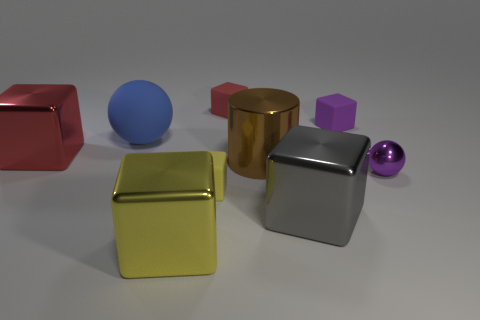Subtract 1 cubes. How many cubes are left? 5 Subtract all purple cubes. How many cubes are left? 5 Subtract all yellow metal blocks. How many blocks are left? 5 Subtract all green blocks. Subtract all brown spheres. How many blocks are left? 6 Add 1 tiny metal balls. How many objects exist? 10 Subtract all cubes. How many objects are left? 3 Subtract all tiny cyan blocks. Subtract all matte cubes. How many objects are left? 6 Add 4 brown metallic things. How many brown metallic things are left? 5 Add 9 big gray cubes. How many big gray cubes exist? 10 Subtract 1 brown cylinders. How many objects are left? 8 